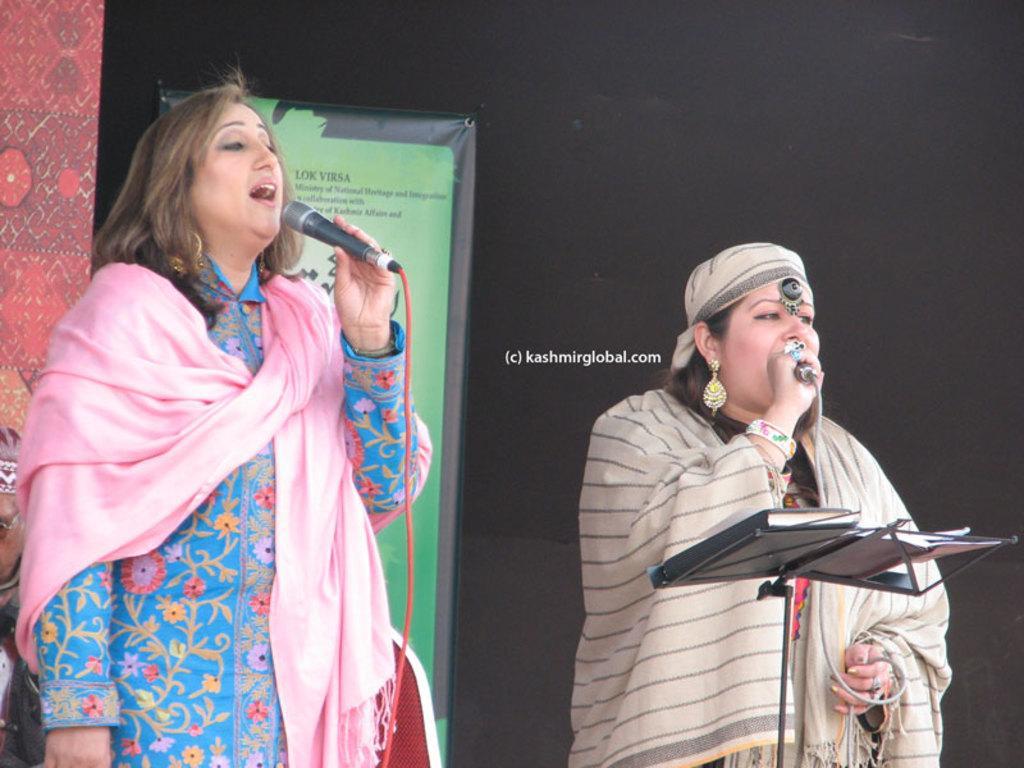Please provide a concise description of this image. In this picture there are two women, who are holding a mic. She is standing near to the speech desk. On this desk we can see papers and books. On the back there is a green color banner. On the left we can see red color banner. In the center we can see a watermark. On the top right there is a dark. 